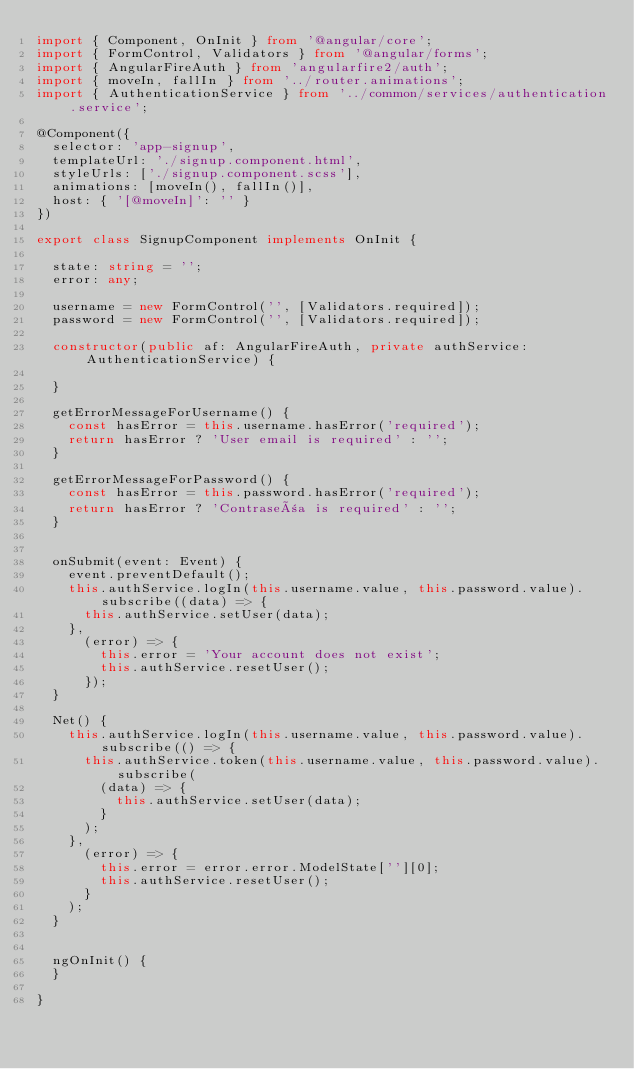Convert code to text. <code><loc_0><loc_0><loc_500><loc_500><_TypeScript_>import { Component, OnInit } from '@angular/core';
import { FormControl, Validators } from '@angular/forms';
import { AngularFireAuth } from 'angularfire2/auth';
import { moveIn, fallIn } from '../router.animations';
import { AuthenticationService } from '../common/services/authentication.service';

@Component({
  selector: 'app-signup',
  templateUrl: './signup.component.html',
  styleUrls: ['./signup.component.scss'],
  animations: [moveIn(), fallIn()],
  host: { '[@moveIn]': '' }
})

export class SignupComponent implements OnInit {

  state: string = '';
  error: any;

  username = new FormControl('', [Validators.required]);
  password = new FormControl('', [Validators.required]);

  constructor(public af: AngularFireAuth, private authService: AuthenticationService) {

  }

  getErrorMessageForUsername() {
    const hasError = this.username.hasError('required');
    return hasError ? 'User email is required' : '';
  }

  getErrorMessageForPassword() {
    const hasError = this.password.hasError('required');
    return hasError ? 'Contraseña is required' : '';
  }


  onSubmit(event: Event) {
    event.preventDefault();
    this.authService.logIn(this.username.value, this.password.value).subscribe((data) => {
      this.authService.setUser(data);
    },
      (error) => {
        this.error = 'Your account does not exist';
        this.authService.resetUser();
      });
  }

  Net() {
    this.authService.logIn(this.username.value, this.password.value).subscribe(() => {
      this.authService.token(this.username.value, this.password.value).subscribe(
        (data) => {
          this.authService.setUser(data);
        }
      );
    },
      (error) => {
        this.error = error.error.ModelState[''][0];
        this.authService.resetUser();
      }
    );
  }


  ngOnInit() {
  }

}
</code> 